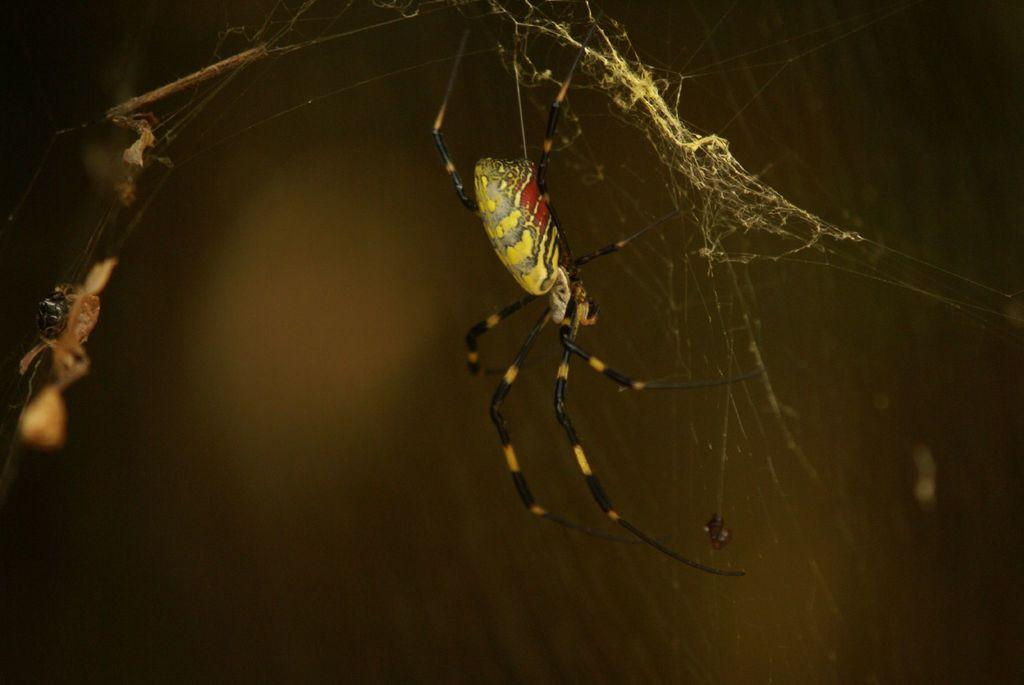How many insects can be seen in the image? There are two insects in the image. What is present in the image that insects might use for shelter or food? There is a spider web in the image. Can you describe the background of the image? The background of the image is blurry. What type of fowl can be seen in the image? There is no fowl present in the image; it features two insects and a spider web. Can you tell me what the insects are discussing in the image? Insects do not have the ability to engage in discussions, and there is no indication of any such activity in the image. 